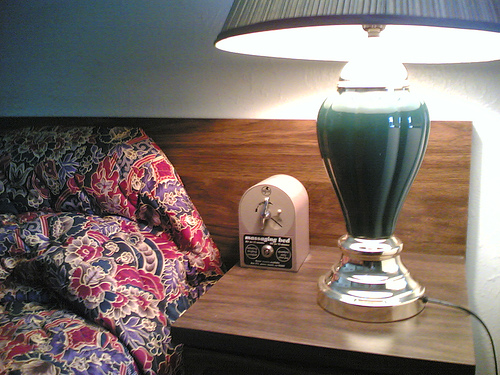<image>
Can you confirm if the lamp is to the right of the bed? Yes. From this viewpoint, the lamp is positioned to the right side relative to the bed. 